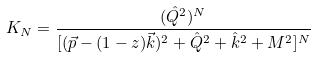<formula> <loc_0><loc_0><loc_500><loc_500>K _ { N } = \frac { ( \hat { Q } ^ { 2 } ) ^ { N } } { [ ( \vec { p } - ( 1 - z ) \vec { k } ) ^ { 2 } + \hat { Q } ^ { 2 } + \hat { k } ^ { 2 } + M ^ { 2 } ] ^ { N } }</formula> 